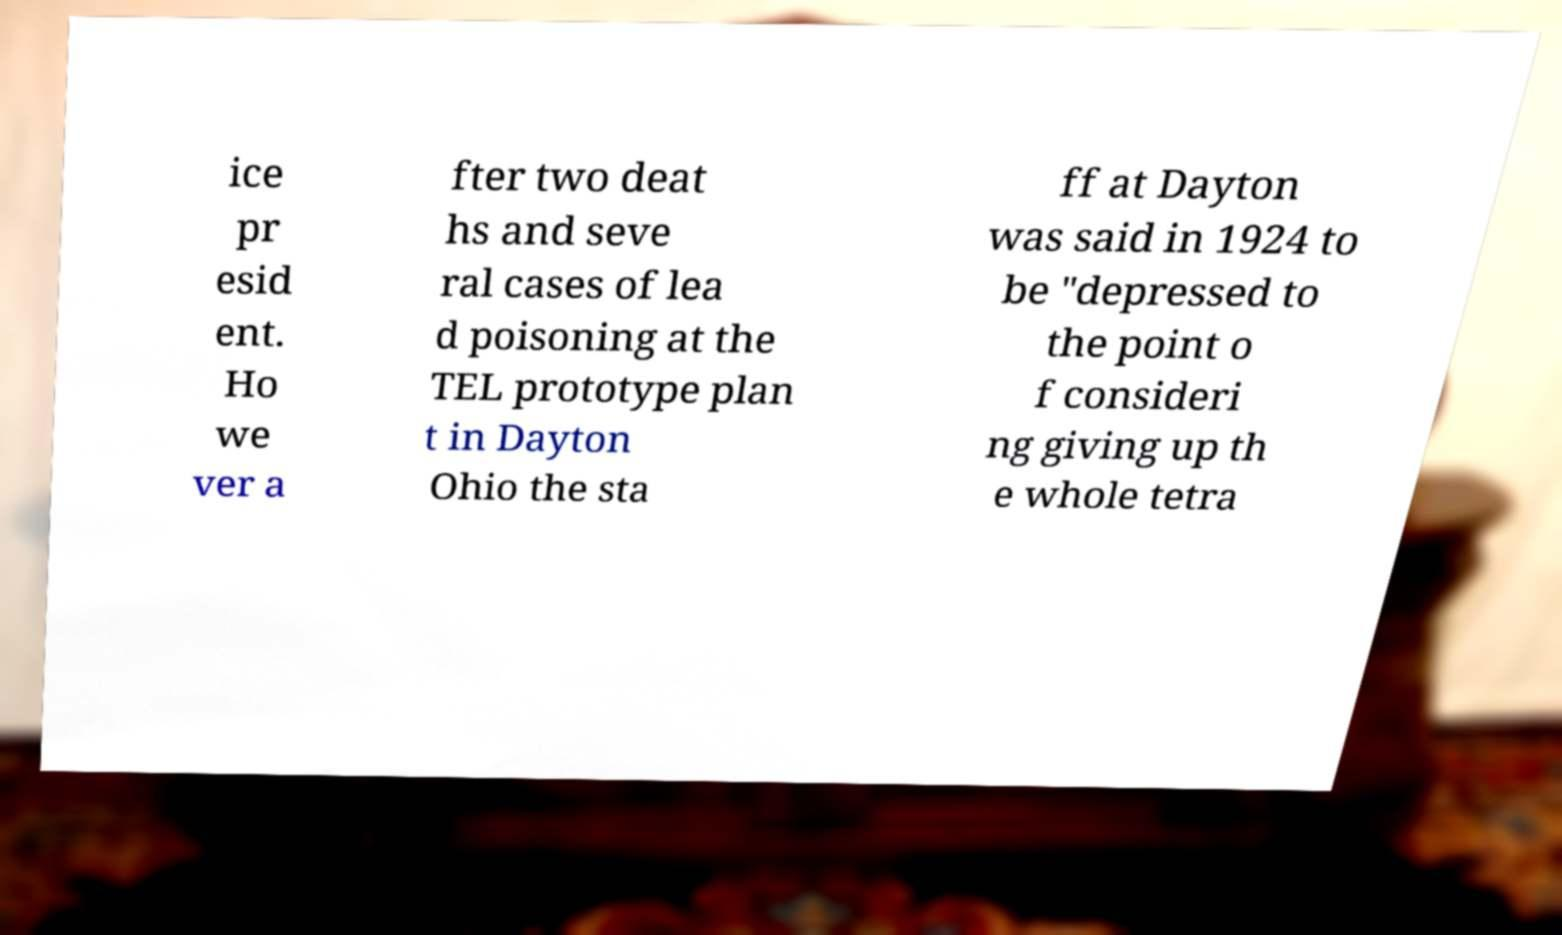Can you accurately transcribe the text from the provided image for me? ice pr esid ent. Ho we ver a fter two deat hs and seve ral cases of lea d poisoning at the TEL prototype plan t in Dayton Ohio the sta ff at Dayton was said in 1924 to be "depressed to the point o f consideri ng giving up th e whole tetra 